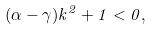<formula> <loc_0><loc_0><loc_500><loc_500>( \alpha - \gamma ) k ^ { 2 } + 1 < 0 ,</formula> 